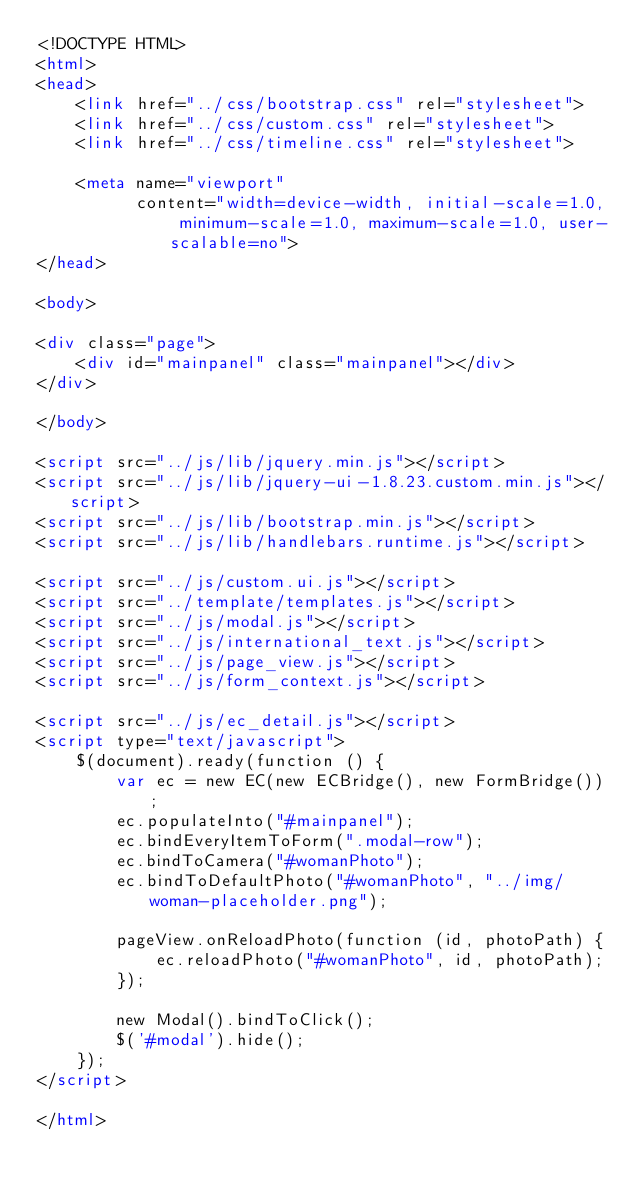<code> <loc_0><loc_0><loc_500><loc_500><_HTML_><!DOCTYPE HTML>
<html>
<head>
    <link href="../css/bootstrap.css" rel="stylesheet">
    <link href="../css/custom.css" rel="stylesheet">
    <link href="../css/timeline.css" rel="stylesheet">

    <meta name="viewport"
          content="width=device-width, initial-scale=1.0, minimum-scale=1.0, maximum-scale=1.0, user-scalable=no">
</head>

<body>

<div class="page">
    <div id="mainpanel" class="mainpanel"></div>
</div>

</body>

<script src="../js/lib/jquery.min.js"></script>
<script src="../js/lib/jquery-ui-1.8.23.custom.min.js"></script>
<script src="../js/lib/bootstrap.min.js"></script>
<script src="../js/lib/handlebars.runtime.js"></script>

<script src="../js/custom.ui.js"></script>
<script src="../template/templates.js"></script>
<script src="../js/modal.js"></script>
<script src="../js/international_text.js"></script>
<script src="../js/page_view.js"></script>
<script src="../js/form_context.js"></script>

<script src="../js/ec_detail.js"></script>
<script type="text/javascript">
    $(document).ready(function () {
        var ec = new EC(new ECBridge(), new FormBridge());
        ec.populateInto("#mainpanel");
        ec.bindEveryItemToForm(".modal-row");
        ec.bindToCamera("#womanPhoto");
        ec.bindToDefaultPhoto("#womanPhoto", "../img/woman-placeholder.png");

        pageView.onReloadPhoto(function (id, photoPath) {
            ec.reloadPhoto("#womanPhoto", id, photoPath);
        });

        new Modal().bindToClick();
        $('#modal').hide();
    });
</script>

</html>
</code> 